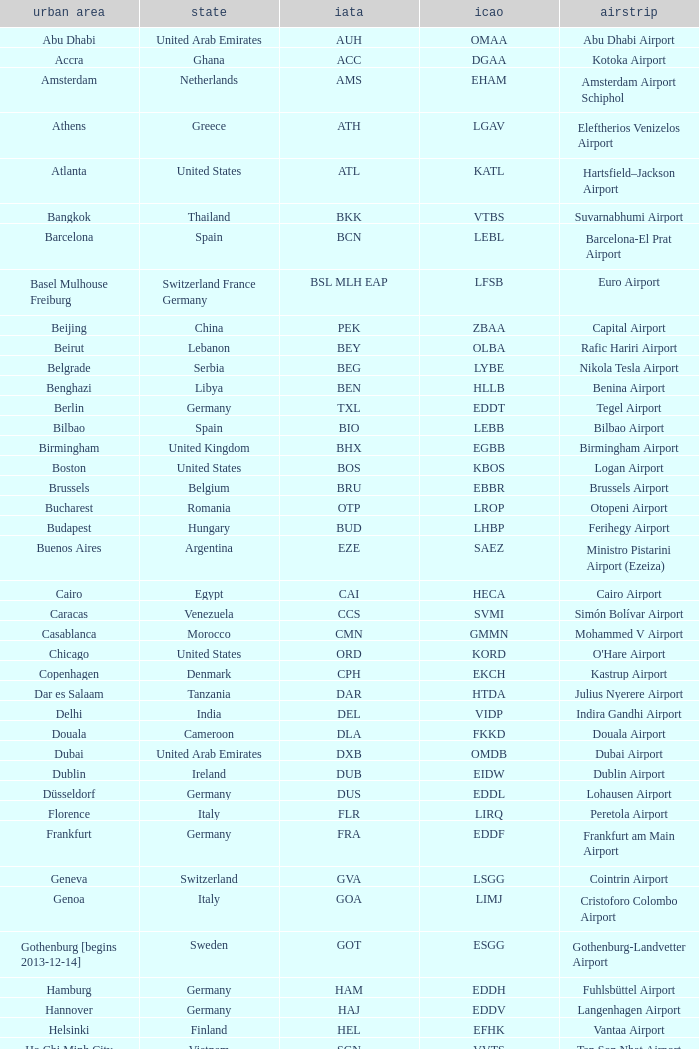What is the ICAO of Douala city? FKKD. 